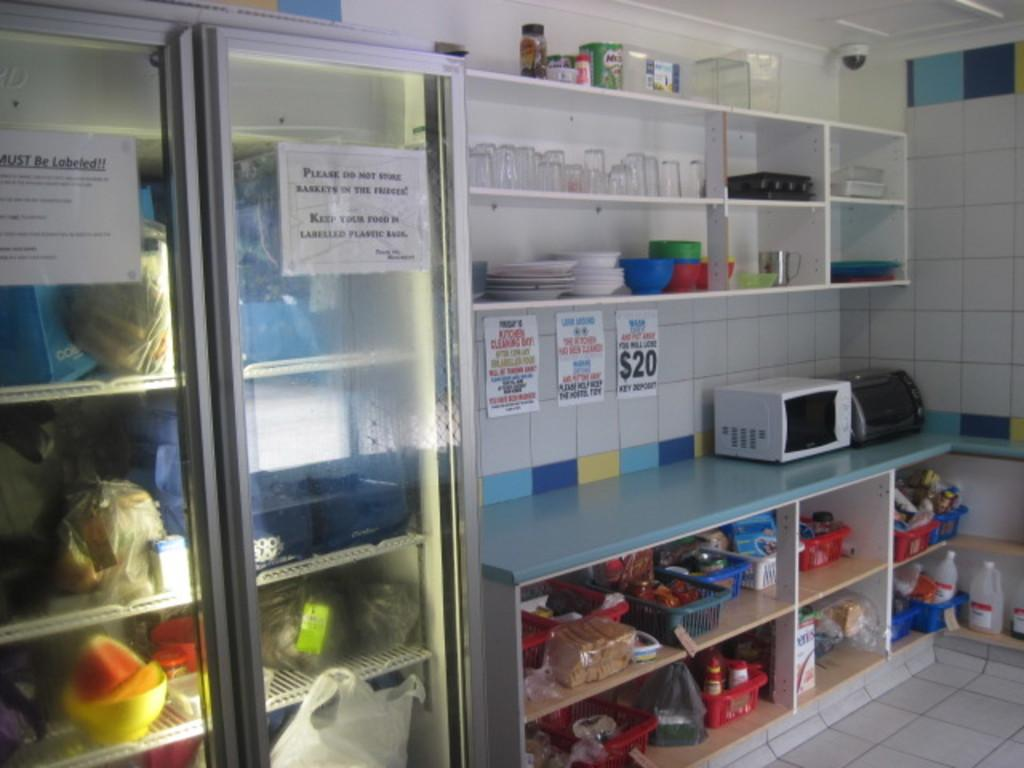<image>
Relay a brief, clear account of the picture shown. A kitchen or break room area with a refrigerator that has a note attached to the door reminding people to keep their food in labeled boxes. 